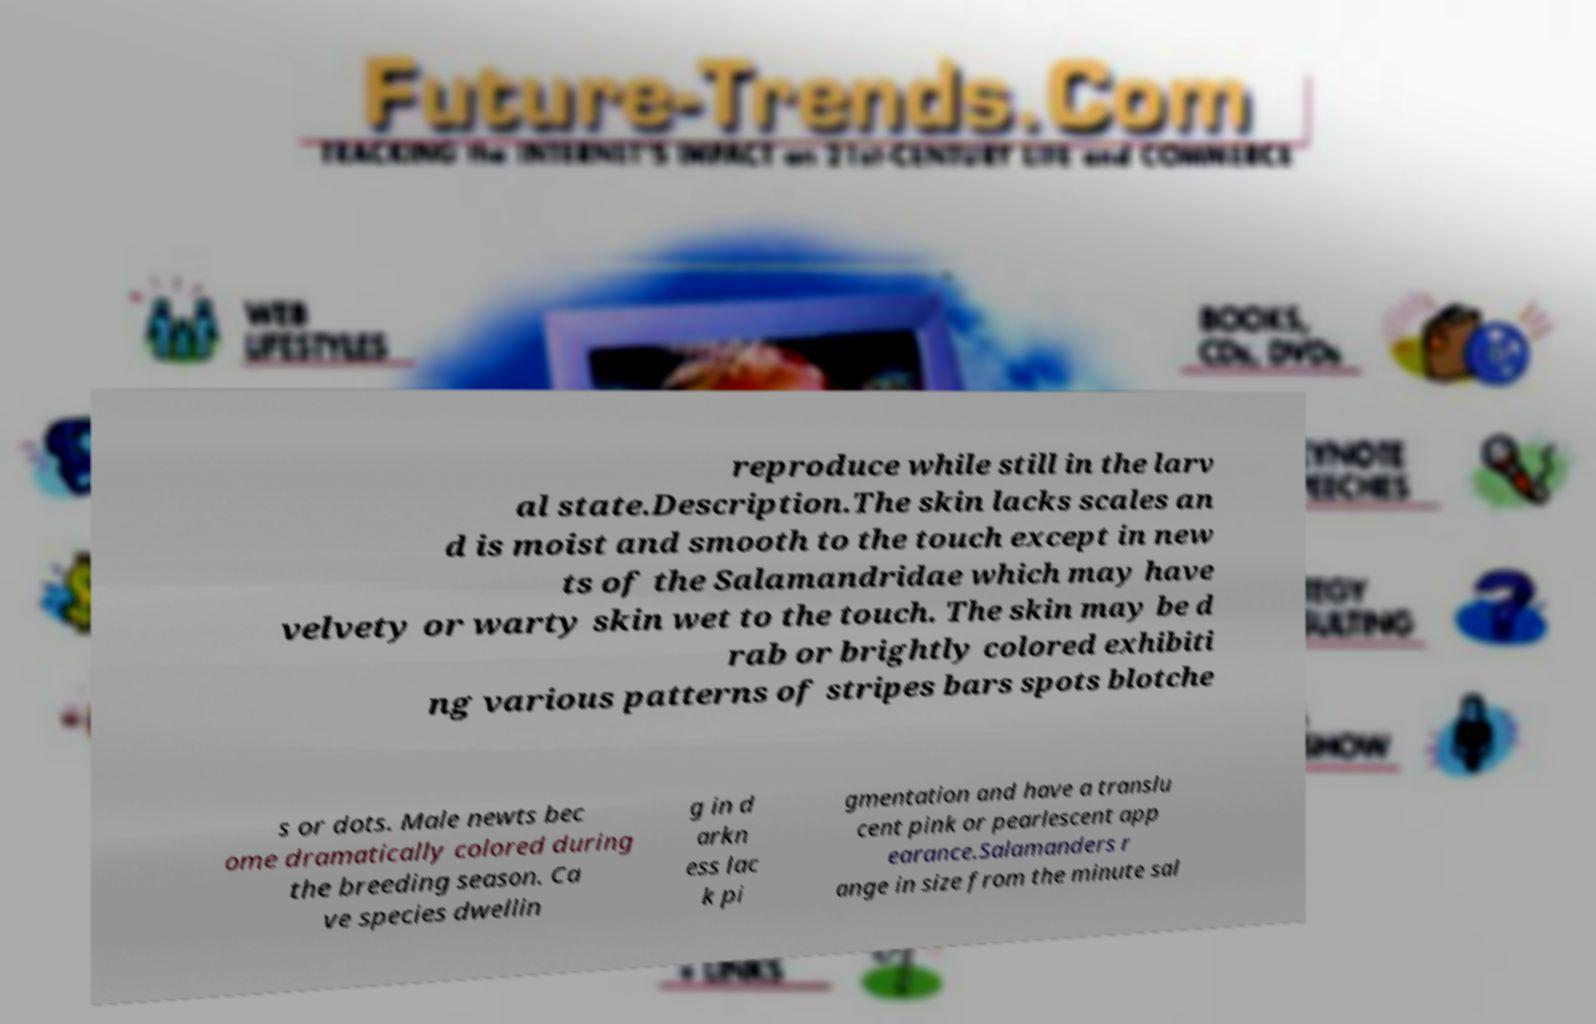Can you accurately transcribe the text from the provided image for me? reproduce while still in the larv al state.Description.The skin lacks scales an d is moist and smooth to the touch except in new ts of the Salamandridae which may have velvety or warty skin wet to the touch. The skin may be d rab or brightly colored exhibiti ng various patterns of stripes bars spots blotche s or dots. Male newts bec ome dramatically colored during the breeding season. Ca ve species dwellin g in d arkn ess lac k pi gmentation and have a translu cent pink or pearlescent app earance.Salamanders r ange in size from the minute sal 